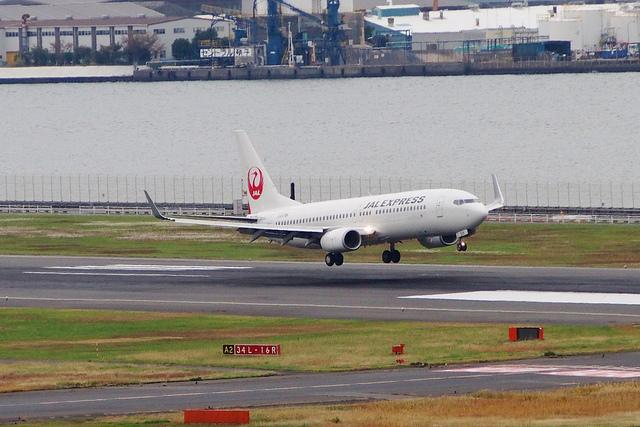In which country is this airport located?

Choices:
A) korea
B) japan
C) india
D) china japan 